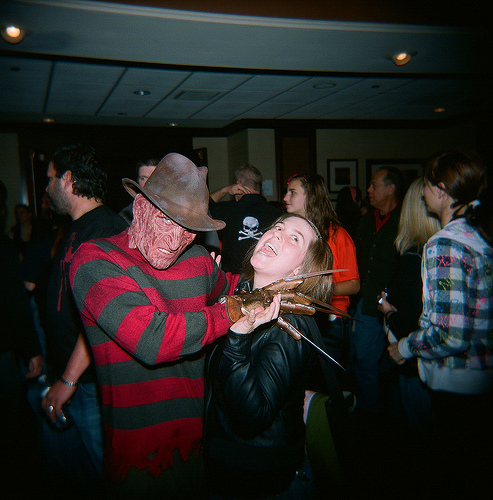<image>
Is there a knife next to the girl? Yes. The knife is positioned adjacent to the girl, located nearby in the same general area. 